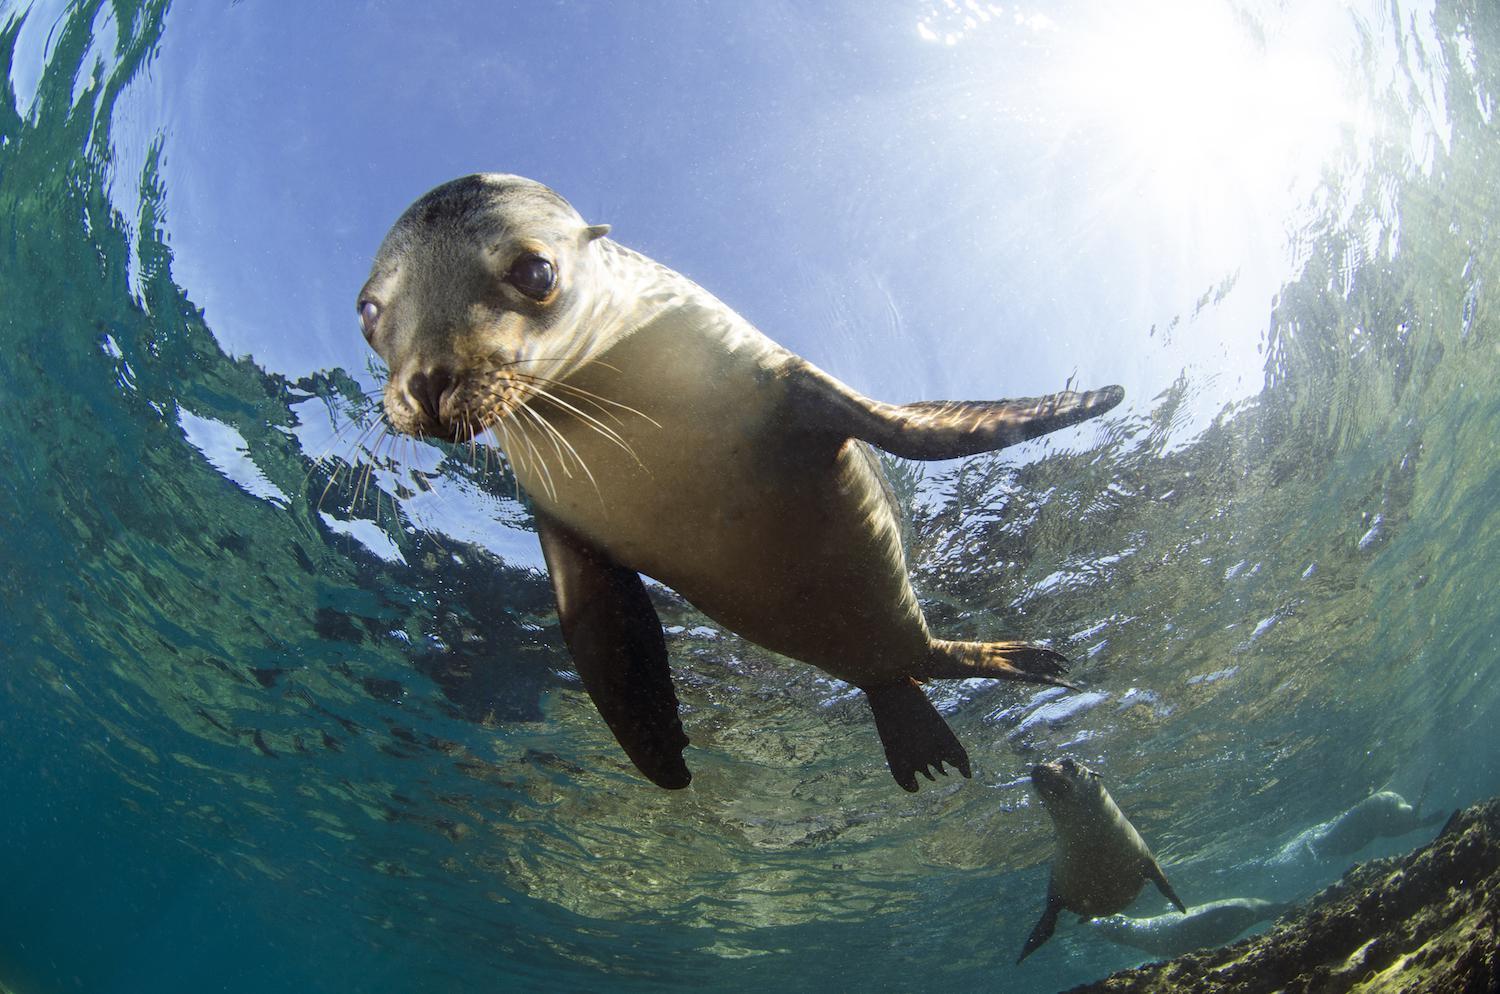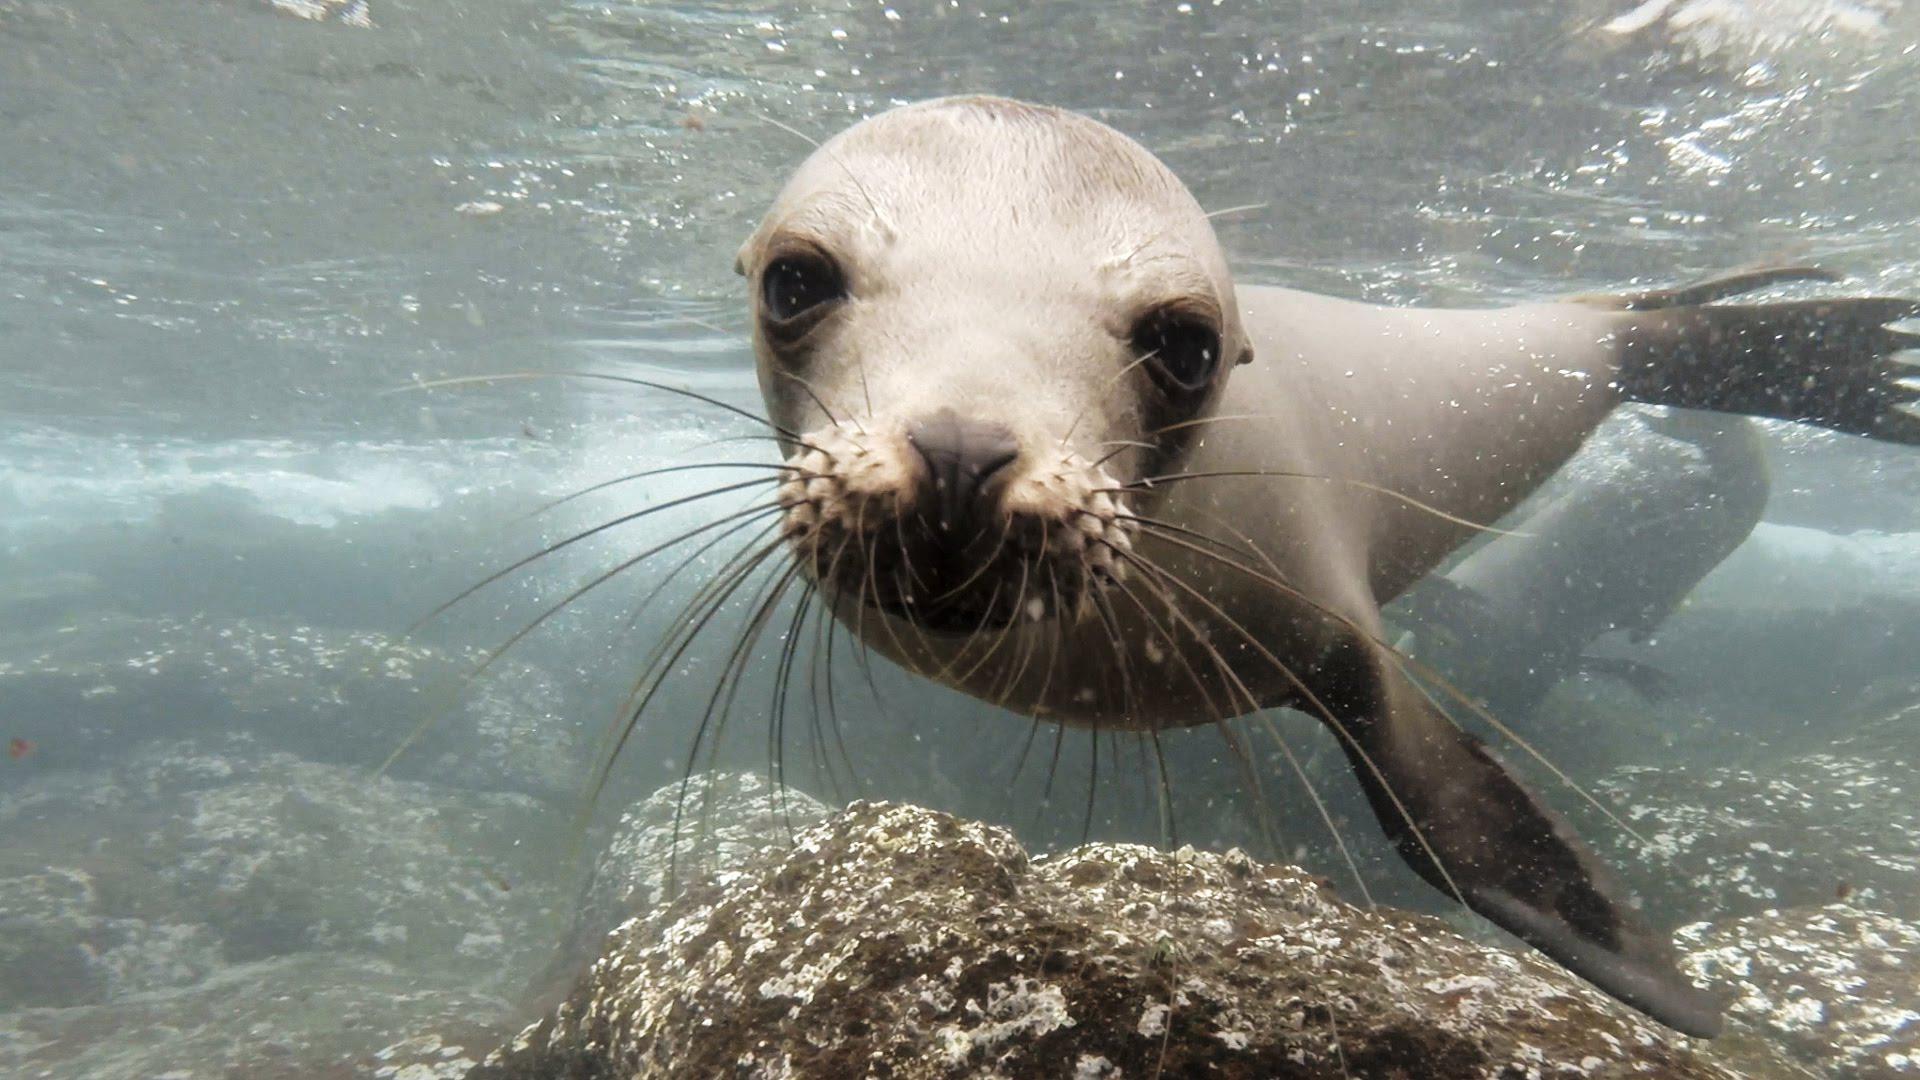The first image is the image on the left, the second image is the image on the right. For the images shown, is this caption "There are seals underwater" true? Answer yes or no. Yes. The first image is the image on the left, the second image is the image on the right. For the images displayed, is the sentence "There is no less than one seal swimming underwater" factually correct? Answer yes or no. Yes. 